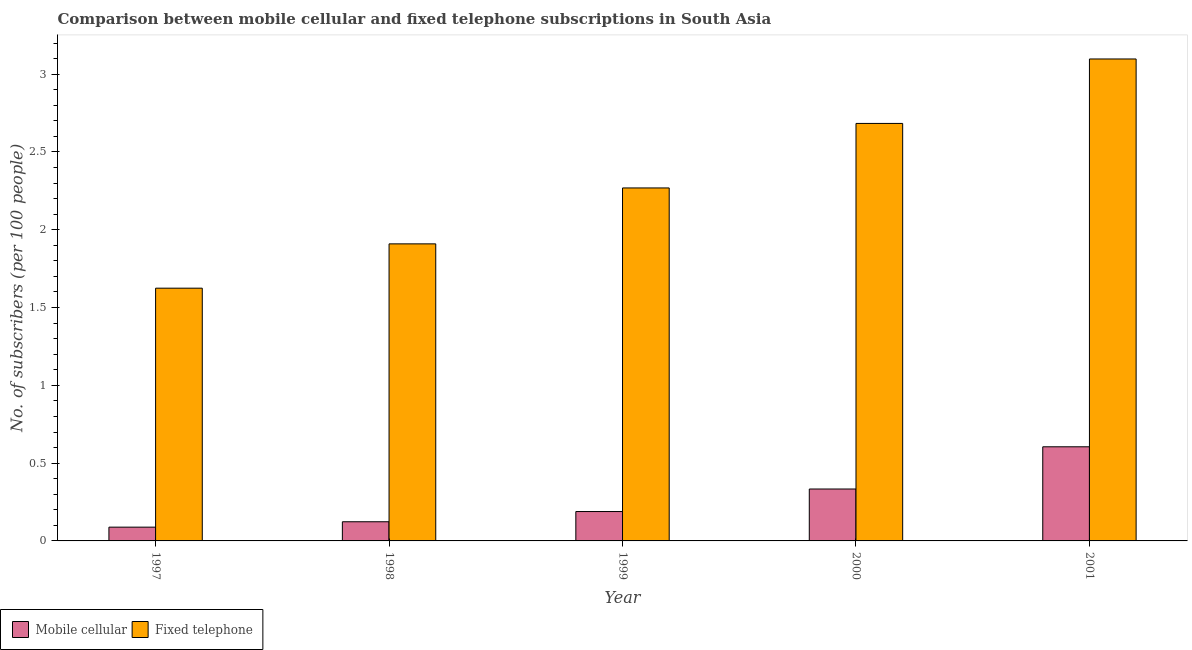How many different coloured bars are there?
Offer a very short reply. 2. How many groups of bars are there?
Provide a succinct answer. 5. Are the number of bars on each tick of the X-axis equal?
Your response must be concise. Yes. How many bars are there on the 3rd tick from the right?
Make the answer very short. 2. What is the label of the 1st group of bars from the left?
Your answer should be compact. 1997. What is the number of mobile cellular subscribers in 1997?
Give a very brief answer. 0.09. Across all years, what is the maximum number of mobile cellular subscribers?
Your answer should be compact. 0.61. Across all years, what is the minimum number of fixed telephone subscribers?
Your response must be concise. 1.62. What is the total number of mobile cellular subscribers in the graph?
Provide a succinct answer. 1.34. What is the difference between the number of mobile cellular subscribers in 1998 and that in 2001?
Give a very brief answer. -0.48. What is the difference between the number of fixed telephone subscribers in 2000 and the number of mobile cellular subscribers in 1999?
Ensure brevity in your answer.  0.41. What is the average number of fixed telephone subscribers per year?
Your answer should be compact. 2.32. What is the ratio of the number of mobile cellular subscribers in 1998 to that in 2000?
Offer a terse response. 0.37. What is the difference between the highest and the second highest number of fixed telephone subscribers?
Your response must be concise. 0.41. What is the difference between the highest and the lowest number of fixed telephone subscribers?
Your answer should be very brief. 1.47. Is the sum of the number of mobile cellular subscribers in 1998 and 2000 greater than the maximum number of fixed telephone subscribers across all years?
Provide a succinct answer. No. What does the 1st bar from the left in 1998 represents?
Make the answer very short. Mobile cellular. What does the 2nd bar from the right in 1998 represents?
Your response must be concise. Mobile cellular. Are all the bars in the graph horizontal?
Your response must be concise. No. Are the values on the major ticks of Y-axis written in scientific E-notation?
Keep it short and to the point. No. Does the graph contain any zero values?
Give a very brief answer. No. Does the graph contain grids?
Give a very brief answer. No. How are the legend labels stacked?
Provide a short and direct response. Horizontal. What is the title of the graph?
Ensure brevity in your answer.  Comparison between mobile cellular and fixed telephone subscriptions in South Asia. What is the label or title of the Y-axis?
Keep it short and to the point. No. of subscribers (per 100 people). What is the No. of subscribers (per 100 people) in Mobile cellular in 1997?
Your answer should be compact. 0.09. What is the No. of subscribers (per 100 people) in Fixed telephone in 1997?
Your response must be concise. 1.62. What is the No. of subscribers (per 100 people) in Mobile cellular in 1998?
Your answer should be very brief. 0.12. What is the No. of subscribers (per 100 people) of Fixed telephone in 1998?
Provide a succinct answer. 1.91. What is the No. of subscribers (per 100 people) of Mobile cellular in 1999?
Keep it short and to the point. 0.19. What is the No. of subscribers (per 100 people) of Fixed telephone in 1999?
Provide a short and direct response. 2.27. What is the No. of subscribers (per 100 people) in Mobile cellular in 2000?
Your answer should be compact. 0.33. What is the No. of subscribers (per 100 people) of Fixed telephone in 2000?
Your answer should be very brief. 2.68. What is the No. of subscribers (per 100 people) in Mobile cellular in 2001?
Your answer should be very brief. 0.61. What is the No. of subscribers (per 100 people) of Fixed telephone in 2001?
Keep it short and to the point. 3.1. Across all years, what is the maximum No. of subscribers (per 100 people) in Mobile cellular?
Provide a succinct answer. 0.61. Across all years, what is the maximum No. of subscribers (per 100 people) in Fixed telephone?
Make the answer very short. 3.1. Across all years, what is the minimum No. of subscribers (per 100 people) of Mobile cellular?
Offer a terse response. 0.09. Across all years, what is the minimum No. of subscribers (per 100 people) of Fixed telephone?
Your answer should be very brief. 1.62. What is the total No. of subscribers (per 100 people) in Mobile cellular in the graph?
Provide a succinct answer. 1.34. What is the total No. of subscribers (per 100 people) of Fixed telephone in the graph?
Keep it short and to the point. 11.58. What is the difference between the No. of subscribers (per 100 people) in Mobile cellular in 1997 and that in 1998?
Your answer should be very brief. -0.03. What is the difference between the No. of subscribers (per 100 people) of Fixed telephone in 1997 and that in 1998?
Your response must be concise. -0.28. What is the difference between the No. of subscribers (per 100 people) of Mobile cellular in 1997 and that in 1999?
Your answer should be compact. -0.1. What is the difference between the No. of subscribers (per 100 people) in Fixed telephone in 1997 and that in 1999?
Your answer should be compact. -0.64. What is the difference between the No. of subscribers (per 100 people) in Mobile cellular in 1997 and that in 2000?
Provide a succinct answer. -0.25. What is the difference between the No. of subscribers (per 100 people) in Fixed telephone in 1997 and that in 2000?
Provide a succinct answer. -1.06. What is the difference between the No. of subscribers (per 100 people) in Mobile cellular in 1997 and that in 2001?
Ensure brevity in your answer.  -0.52. What is the difference between the No. of subscribers (per 100 people) in Fixed telephone in 1997 and that in 2001?
Provide a succinct answer. -1.47. What is the difference between the No. of subscribers (per 100 people) of Mobile cellular in 1998 and that in 1999?
Your answer should be compact. -0.07. What is the difference between the No. of subscribers (per 100 people) in Fixed telephone in 1998 and that in 1999?
Offer a very short reply. -0.36. What is the difference between the No. of subscribers (per 100 people) of Mobile cellular in 1998 and that in 2000?
Your answer should be very brief. -0.21. What is the difference between the No. of subscribers (per 100 people) of Fixed telephone in 1998 and that in 2000?
Offer a very short reply. -0.77. What is the difference between the No. of subscribers (per 100 people) in Mobile cellular in 1998 and that in 2001?
Offer a terse response. -0.48. What is the difference between the No. of subscribers (per 100 people) of Fixed telephone in 1998 and that in 2001?
Offer a terse response. -1.19. What is the difference between the No. of subscribers (per 100 people) in Mobile cellular in 1999 and that in 2000?
Provide a short and direct response. -0.14. What is the difference between the No. of subscribers (per 100 people) of Fixed telephone in 1999 and that in 2000?
Ensure brevity in your answer.  -0.41. What is the difference between the No. of subscribers (per 100 people) in Mobile cellular in 1999 and that in 2001?
Provide a short and direct response. -0.42. What is the difference between the No. of subscribers (per 100 people) in Fixed telephone in 1999 and that in 2001?
Keep it short and to the point. -0.83. What is the difference between the No. of subscribers (per 100 people) of Mobile cellular in 2000 and that in 2001?
Offer a terse response. -0.27. What is the difference between the No. of subscribers (per 100 people) in Fixed telephone in 2000 and that in 2001?
Your answer should be very brief. -0.41. What is the difference between the No. of subscribers (per 100 people) in Mobile cellular in 1997 and the No. of subscribers (per 100 people) in Fixed telephone in 1998?
Give a very brief answer. -1.82. What is the difference between the No. of subscribers (per 100 people) in Mobile cellular in 1997 and the No. of subscribers (per 100 people) in Fixed telephone in 1999?
Provide a succinct answer. -2.18. What is the difference between the No. of subscribers (per 100 people) of Mobile cellular in 1997 and the No. of subscribers (per 100 people) of Fixed telephone in 2000?
Ensure brevity in your answer.  -2.59. What is the difference between the No. of subscribers (per 100 people) of Mobile cellular in 1997 and the No. of subscribers (per 100 people) of Fixed telephone in 2001?
Your answer should be compact. -3.01. What is the difference between the No. of subscribers (per 100 people) of Mobile cellular in 1998 and the No. of subscribers (per 100 people) of Fixed telephone in 1999?
Your response must be concise. -2.15. What is the difference between the No. of subscribers (per 100 people) in Mobile cellular in 1998 and the No. of subscribers (per 100 people) in Fixed telephone in 2000?
Offer a terse response. -2.56. What is the difference between the No. of subscribers (per 100 people) of Mobile cellular in 1998 and the No. of subscribers (per 100 people) of Fixed telephone in 2001?
Make the answer very short. -2.97. What is the difference between the No. of subscribers (per 100 people) of Mobile cellular in 1999 and the No. of subscribers (per 100 people) of Fixed telephone in 2000?
Your response must be concise. -2.49. What is the difference between the No. of subscribers (per 100 people) of Mobile cellular in 1999 and the No. of subscribers (per 100 people) of Fixed telephone in 2001?
Give a very brief answer. -2.91. What is the difference between the No. of subscribers (per 100 people) in Mobile cellular in 2000 and the No. of subscribers (per 100 people) in Fixed telephone in 2001?
Make the answer very short. -2.76. What is the average No. of subscribers (per 100 people) of Mobile cellular per year?
Your answer should be very brief. 0.27. What is the average No. of subscribers (per 100 people) in Fixed telephone per year?
Offer a very short reply. 2.32. In the year 1997, what is the difference between the No. of subscribers (per 100 people) in Mobile cellular and No. of subscribers (per 100 people) in Fixed telephone?
Offer a terse response. -1.54. In the year 1998, what is the difference between the No. of subscribers (per 100 people) in Mobile cellular and No. of subscribers (per 100 people) in Fixed telephone?
Give a very brief answer. -1.79. In the year 1999, what is the difference between the No. of subscribers (per 100 people) of Mobile cellular and No. of subscribers (per 100 people) of Fixed telephone?
Your answer should be compact. -2.08. In the year 2000, what is the difference between the No. of subscribers (per 100 people) in Mobile cellular and No. of subscribers (per 100 people) in Fixed telephone?
Ensure brevity in your answer.  -2.35. In the year 2001, what is the difference between the No. of subscribers (per 100 people) in Mobile cellular and No. of subscribers (per 100 people) in Fixed telephone?
Your answer should be compact. -2.49. What is the ratio of the No. of subscribers (per 100 people) of Mobile cellular in 1997 to that in 1998?
Keep it short and to the point. 0.72. What is the ratio of the No. of subscribers (per 100 people) in Fixed telephone in 1997 to that in 1998?
Make the answer very short. 0.85. What is the ratio of the No. of subscribers (per 100 people) of Mobile cellular in 1997 to that in 1999?
Your answer should be compact. 0.47. What is the ratio of the No. of subscribers (per 100 people) in Fixed telephone in 1997 to that in 1999?
Give a very brief answer. 0.72. What is the ratio of the No. of subscribers (per 100 people) of Mobile cellular in 1997 to that in 2000?
Offer a terse response. 0.27. What is the ratio of the No. of subscribers (per 100 people) of Fixed telephone in 1997 to that in 2000?
Your answer should be compact. 0.61. What is the ratio of the No. of subscribers (per 100 people) of Mobile cellular in 1997 to that in 2001?
Offer a very short reply. 0.15. What is the ratio of the No. of subscribers (per 100 people) in Fixed telephone in 1997 to that in 2001?
Your answer should be very brief. 0.52. What is the ratio of the No. of subscribers (per 100 people) of Mobile cellular in 1998 to that in 1999?
Offer a very short reply. 0.65. What is the ratio of the No. of subscribers (per 100 people) of Fixed telephone in 1998 to that in 1999?
Provide a succinct answer. 0.84. What is the ratio of the No. of subscribers (per 100 people) in Mobile cellular in 1998 to that in 2000?
Your answer should be compact. 0.37. What is the ratio of the No. of subscribers (per 100 people) in Fixed telephone in 1998 to that in 2000?
Your answer should be compact. 0.71. What is the ratio of the No. of subscribers (per 100 people) in Mobile cellular in 1998 to that in 2001?
Your answer should be very brief. 0.2. What is the ratio of the No. of subscribers (per 100 people) in Fixed telephone in 1998 to that in 2001?
Provide a short and direct response. 0.62. What is the ratio of the No. of subscribers (per 100 people) in Mobile cellular in 1999 to that in 2000?
Make the answer very short. 0.57. What is the ratio of the No. of subscribers (per 100 people) of Fixed telephone in 1999 to that in 2000?
Make the answer very short. 0.85. What is the ratio of the No. of subscribers (per 100 people) of Mobile cellular in 1999 to that in 2001?
Your answer should be compact. 0.31. What is the ratio of the No. of subscribers (per 100 people) of Fixed telephone in 1999 to that in 2001?
Keep it short and to the point. 0.73. What is the ratio of the No. of subscribers (per 100 people) of Mobile cellular in 2000 to that in 2001?
Make the answer very short. 0.55. What is the ratio of the No. of subscribers (per 100 people) of Fixed telephone in 2000 to that in 2001?
Ensure brevity in your answer.  0.87. What is the difference between the highest and the second highest No. of subscribers (per 100 people) in Mobile cellular?
Provide a short and direct response. 0.27. What is the difference between the highest and the second highest No. of subscribers (per 100 people) of Fixed telephone?
Provide a succinct answer. 0.41. What is the difference between the highest and the lowest No. of subscribers (per 100 people) of Mobile cellular?
Give a very brief answer. 0.52. What is the difference between the highest and the lowest No. of subscribers (per 100 people) of Fixed telephone?
Make the answer very short. 1.47. 